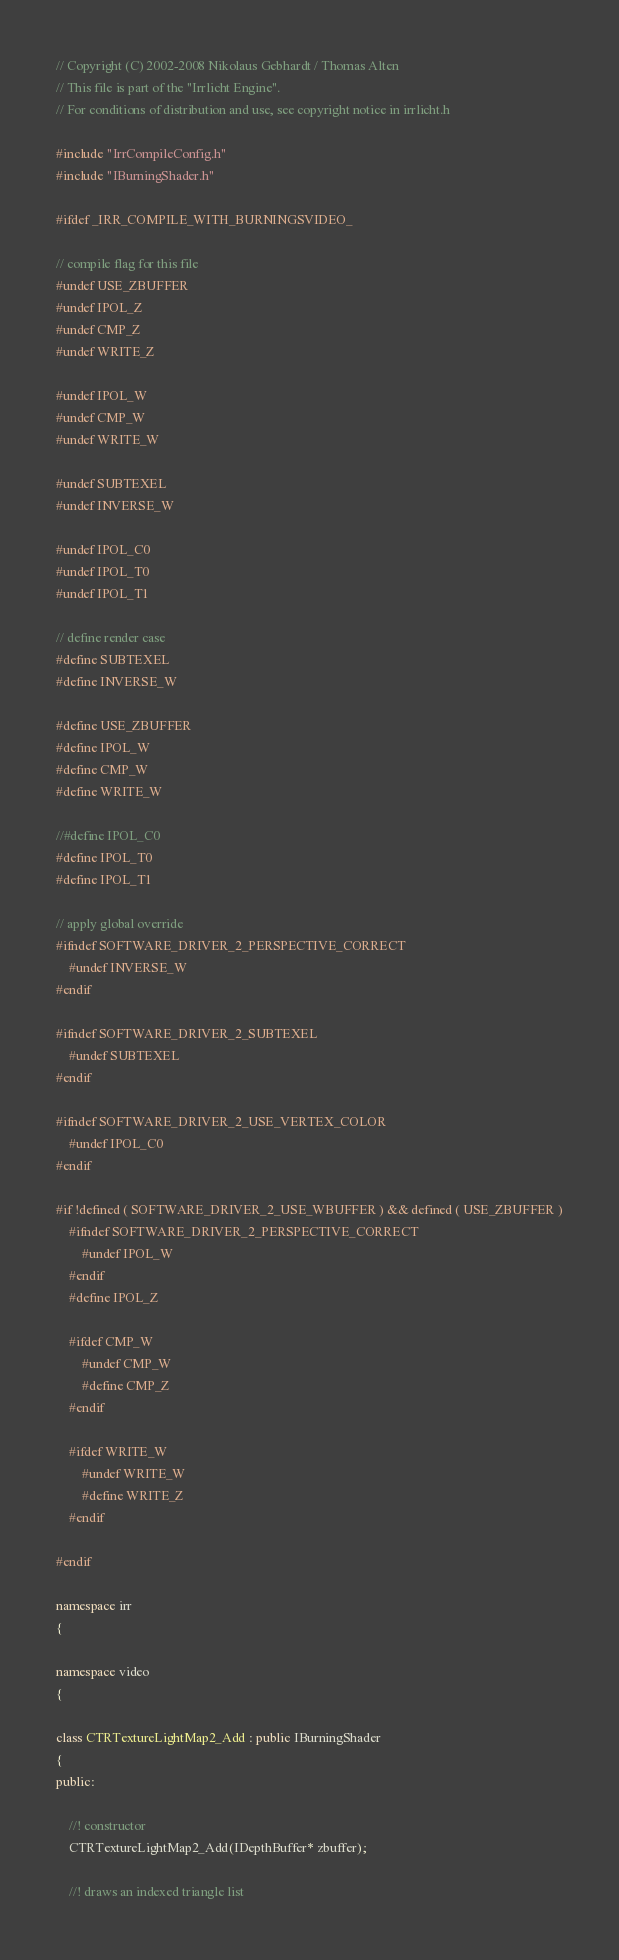<code> <loc_0><loc_0><loc_500><loc_500><_C++_>// Copyright (C) 2002-2008 Nikolaus Gebhardt / Thomas Alten
// This file is part of the "Irrlicht Engine".
// For conditions of distribution and use, see copyright notice in irrlicht.h

#include "IrrCompileConfig.h"
#include "IBurningShader.h"

#ifdef _IRR_COMPILE_WITH_BURNINGSVIDEO_

// compile flag for this file
#undef USE_ZBUFFER
#undef IPOL_Z
#undef CMP_Z
#undef WRITE_Z

#undef IPOL_W
#undef CMP_W
#undef WRITE_W

#undef SUBTEXEL
#undef INVERSE_W

#undef IPOL_C0
#undef IPOL_T0
#undef IPOL_T1

// define render case
#define SUBTEXEL
#define INVERSE_W

#define USE_ZBUFFER
#define IPOL_W
#define CMP_W
#define WRITE_W

//#define IPOL_C0
#define IPOL_T0
#define IPOL_T1

// apply global override
#ifndef SOFTWARE_DRIVER_2_PERSPECTIVE_CORRECT
	#undef INVERSE_W
#endif

#ifndef SOFTWARE_DRIVER_2_SUBTEXEL
	#undef SUBTEXEL
#endif

#ifndef SOFTWARE_DRIVER_2_USE_VERTEX_COLOR
	#undef IPOL_C0
#endif

#if !defined ( SOFTWARE_DRIVER_2_USE_WBUFFER ) && defined ( USE_ZBUFFER )
	#ifndef SOFTWARE_DRIVER_2_PERSPECTIVE_CORRECT
		#undef IPOL_W
	#endif
	#define IPOL_Z

	#ifdef CMP_W
		#undef CMP_W
		#define CMP_Z
	#endif

	#ifdef WRITE_W
		#undef WRITE_W
		#define WRITE_Z
	#endif

#endif

namespace irr
{

namespace video
{

class CTRTextureLightMap2_Add : public IBurningShader
{
public:

	//! constructor
	CTRTextureLightMap2_Add(IDepthBuffer* zbuffer);

	//! draws an indexed triangle list</code> 